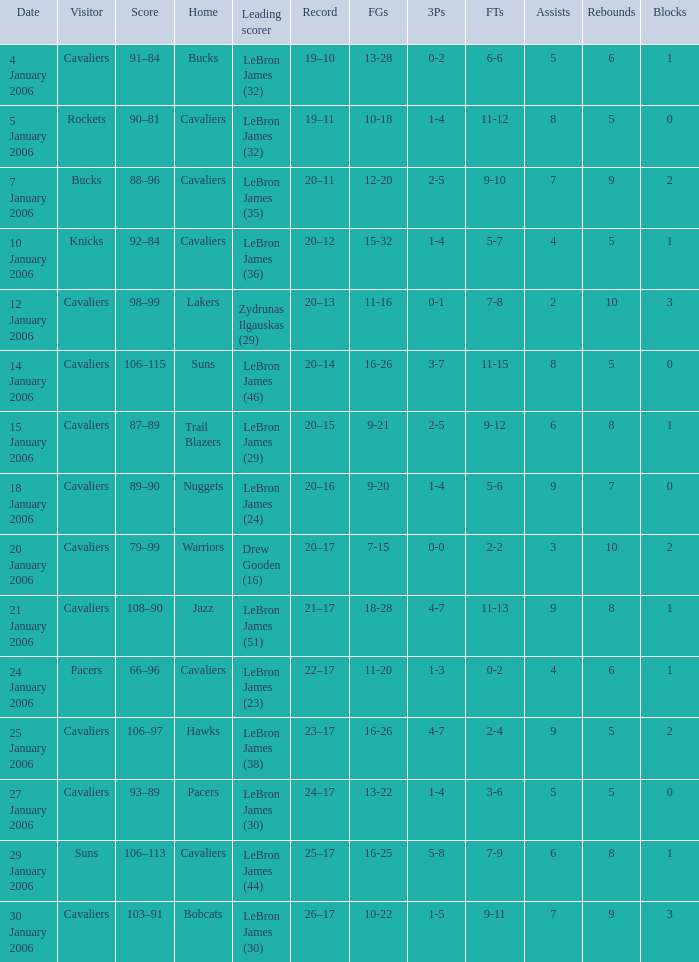Who was the leading score in the game at the Warriors? Drew Gooden (16). 